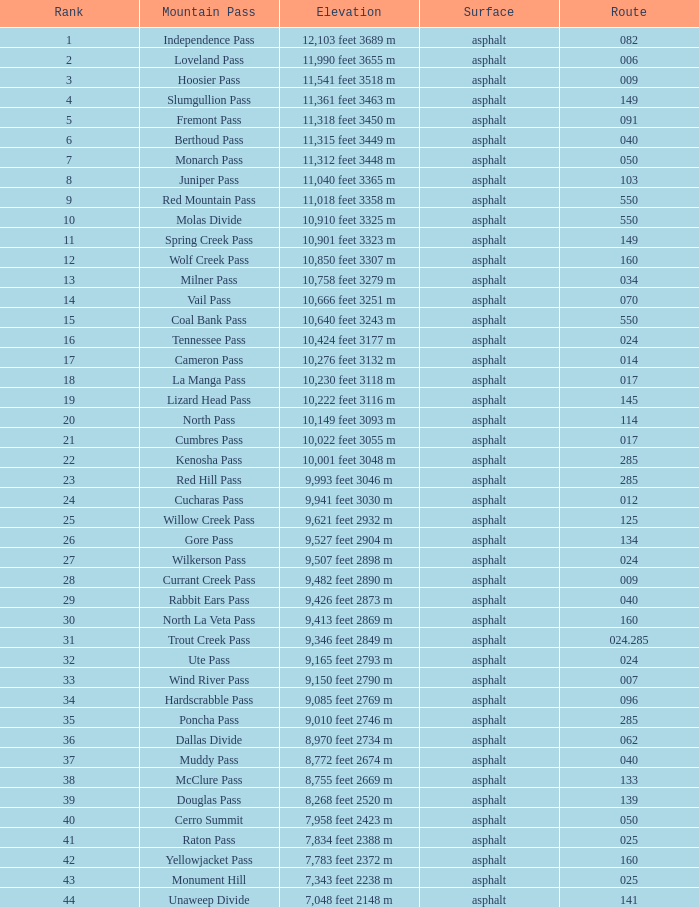What is the surface of the roadway under 7? Asphalt. 